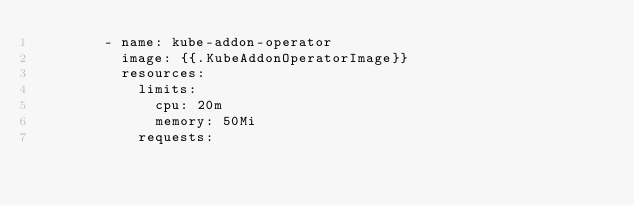Convert code to text. <code><loc_0><loc_0><loc_500><loc_500><_Go_>        - name: kube-addon-operator
          image: {{.KubeAddonOperatorImage}}
          resources:
            limits:
              cpu: 20m
              memory: 50Mi
            requests:</code> 